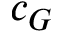<formula> <loc_0><loc_0><loc_500><loc_500>c _ { G }</formula> 